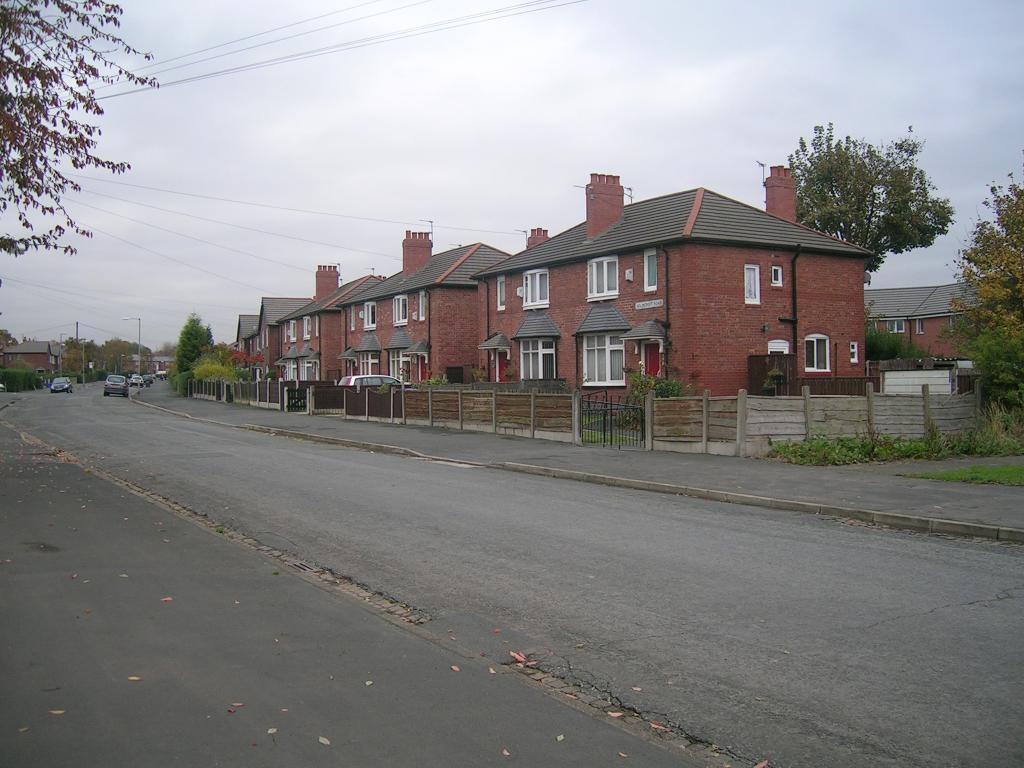What can be seen on the road in the image? There are vehicles on the road in the image. What type of structures are present in the image? There are houses in the image. What are the vertical objects in the image? There are poles in the image. What type of vegetation is present in the image? There are trees and plants in the image. What can be seen inside the houses in the image? There are windows visible in the image. What is visible in the background of the image? The sky is visible in the background of the image. How many brothers are standing near the scarecrow in the image? There is no scarecrow or brothers present in the image. What type of maid can be seen cleaning the plants in the image? There is no maid present in the image; the plants are not being cleaned. 